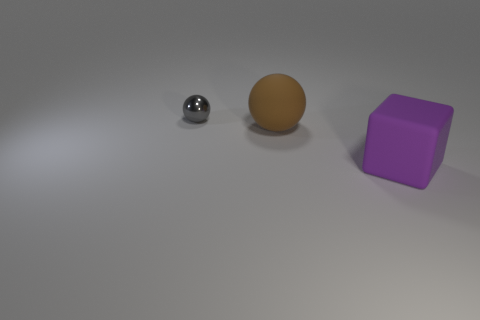Subtract all gray cubes. Subtract all green cylinders. How many cubes are left? 1 Add 3 small shiny balls. How many objects exist? 6 Subtract all cubes. How many objects are left? 2 Subtract all large purple rubber cubes. Subtract all tiny spheres. How many objects are left? 1 Add 2 small gray shiny things. How many small gray shiny things are left? 3 Add 1 brown things. How many brown things exist? 2 Subtract 1 purple blocks. How many objects are left? 2 